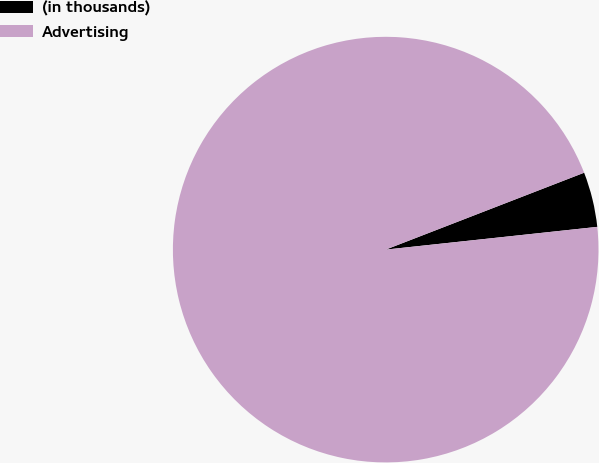Convert chart to OTSL. <chart><loc_0><loc_0><loc_500><loc_500><pie_chart><fcel>(in thousands)<fcel>Advertising<nl><fcel>4.18%<fcel>95.82%<nl></chart> 